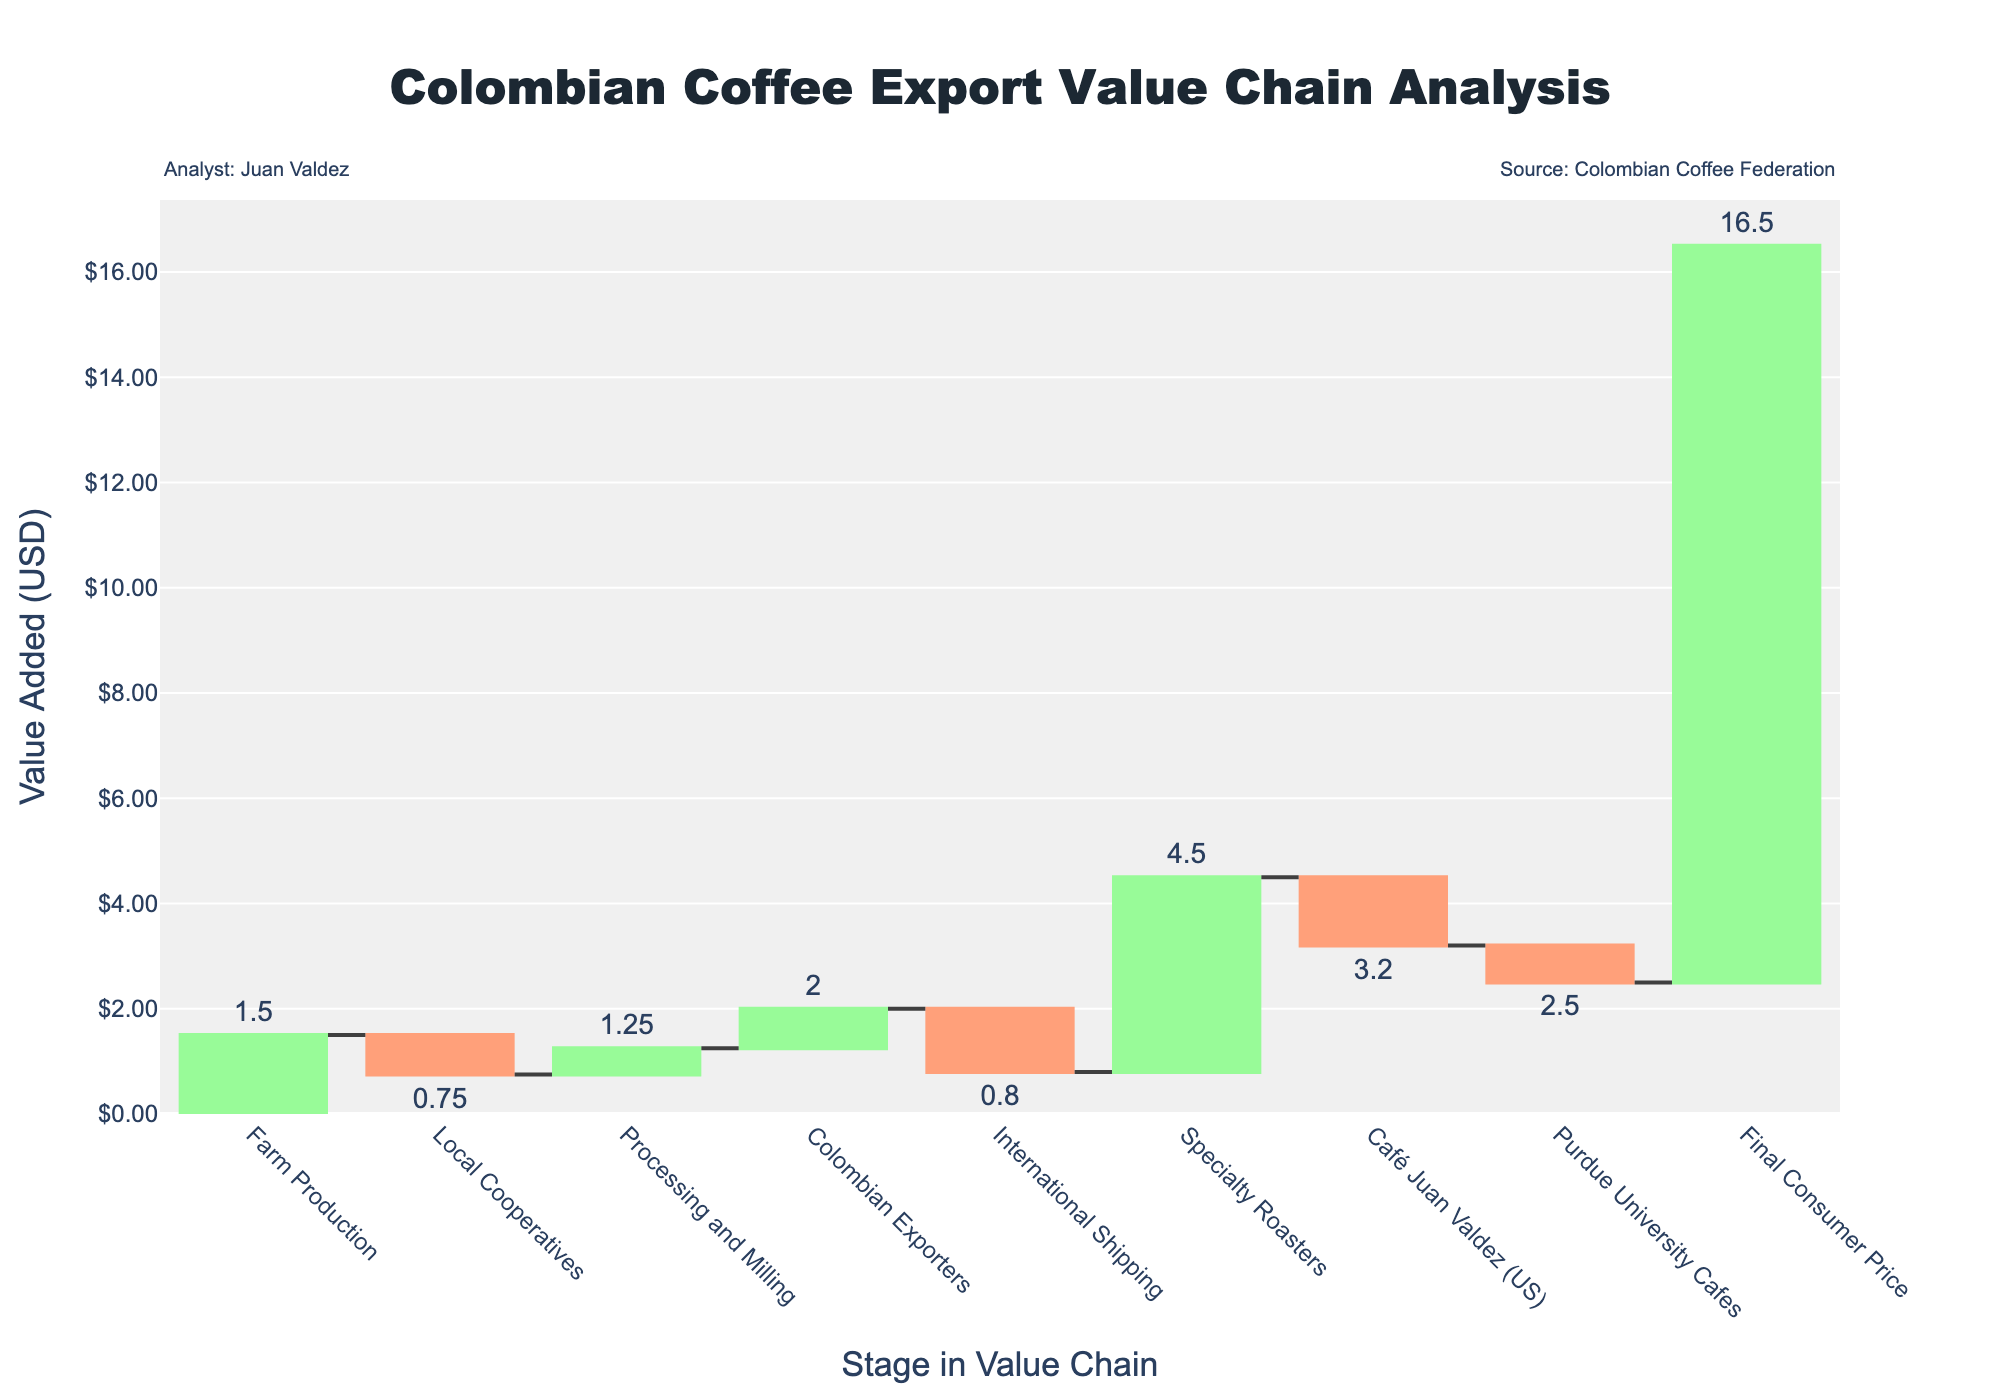What is the title of the chart? The title is usually located at the top of the chart and provides a description of what the chart represents. In this case, the title helps to understand that the chart is analyzing the value added at each stage of the Colombian coffee export value chain.
Answer: Colombian Coffee Export Value Chain Analysis What is the final consumer price for Colombian coffee? The final consumer price is the end value on the waterfall chart, summing all previous stages. Simply look at the last bar in the chart.
Answer: $16.50 Which stage adds the most value to the Colombian coffee export chain? To determine the stage adding the most value, compare the heights of the bars representing each stage. The bar that is the tallest represents the highest value added.
Answer: Specialty Roasters How much value is added by Colombian exporters? Identify the bar labeled "Colombian Exporters" and read the value associated with it.
Answer: $2.00 Compare the value added by Local Cooperatives and International Shipping. Which stage adds more value? Look at the bars for Local Cooperatives and International Shipping, compare their heights, and read their values. The taller bar indicates the stage with more added value.
Answer: Local Cooperatives What is the cumulative value from Farm Production through Processing and Milling? Sum the values of the Farm Production, Local Cooperatives, and Processing and Milling stages: 1.50 + 0.75 + 1.25.
Answer: $3.50 How does the value added at Purdue University Cafes compare to Café Juan Valdez (US)? Compare the heights of the bars for Purdue University Cafes and Café Juan Valdez (US) to see which is taller and read their values.
Answer: Café Juan Valdez (US) adds $0.70 more than Purdue University Cafes What is the total value added from Colombian Exporters to the Final Consumer Price? Sum the values from the Colombian Exporters to the Final Consumer Price: 2.00 (Colombian Exporters) + 0.80 (International Shipping) + 4.50 (Specialty Roasters) + 3.20 (Café Juan Valdez (US)) + 2.50 (Purdue University Cafes).
Answer: $13.00 Is there any stage between Farm Production and Colombian Exporters that adds more value than Farm Production itself? Compare the value of Farm Production with the values added by stages between Farm Production and Colombian Exporters (Local Cooperatives, Processing and Milling). Neither should exceed the value added by Farm Production.
Answer: No What is the difference in value added between the stage with the highest value and the stage with the lowest value? Identify the stages with the highest and lowest values (Specialty Roasters with $4.50 and Local Cooperatives with $0.75) and subtract the lowest value from the highest value: 4.50 - 0.75.
Answer: $3.75 